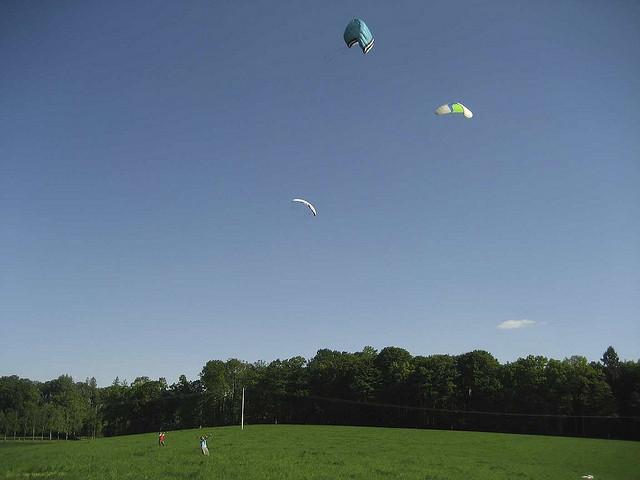What season is shown in the picture?
Give a very brief answer. Summer. How many kites are in the sky?
Be succinct. 3. Does the kite have a tail?
Concise answer only. No. What are they flying?
Answer briefly. Kites. What is floating in the air?
Give a very brief answer. Kites. Are there any round objects in the scene?
Give a very brief answer. No. Are there many clouds in this picture?
Give a very brief answer. No. How many different colors are on the kites tail?
Quick response, please. 3. Is there a lake in the scene?
Answer briefly. No. How many kites are flying?
Keep it brief. 3. Does the grassy area look fairly level?
Concise answer only. Yes. 